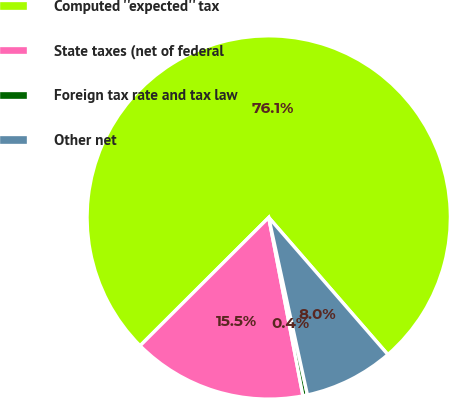Convert chart. <chart><loc_0><loc_0><loc_500><loc_500><pie_chart><fcel>Computed ''expected'' tax<fcel>State taxes (net of federal<fcel>Foreign tax rate and tax law<fcel>Other net<nl><fcel>76.1%<fcel>15.54%<fcel>0.4%<fcel>7.97%<nl></chart> 